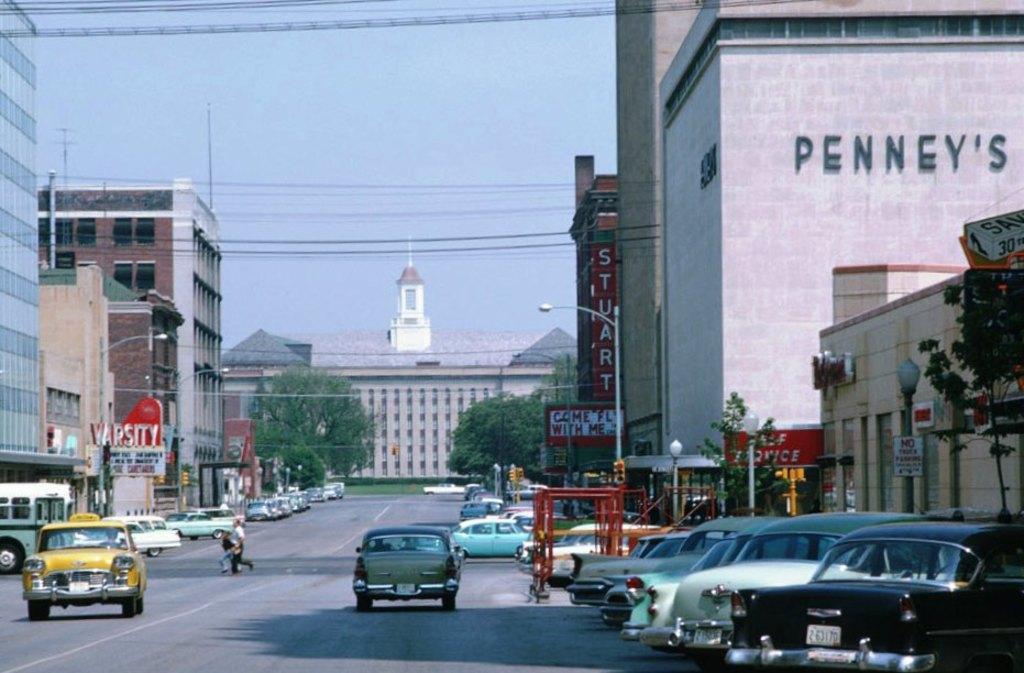<image>
Write a terse but informative summary of the picture. A shop called Stuarts is advertised in red on the right side of the street. 